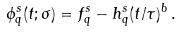Convert formula to latex. <formula><loc_0><loc_0><loc_500><loc_500>\phi ^ { s } _ { q } ( t ; \sigma ) = f ^ { s } _ { q } - h ^ { s } _ { q } ( t / \tau ) ^ { b } \, .</formula> 